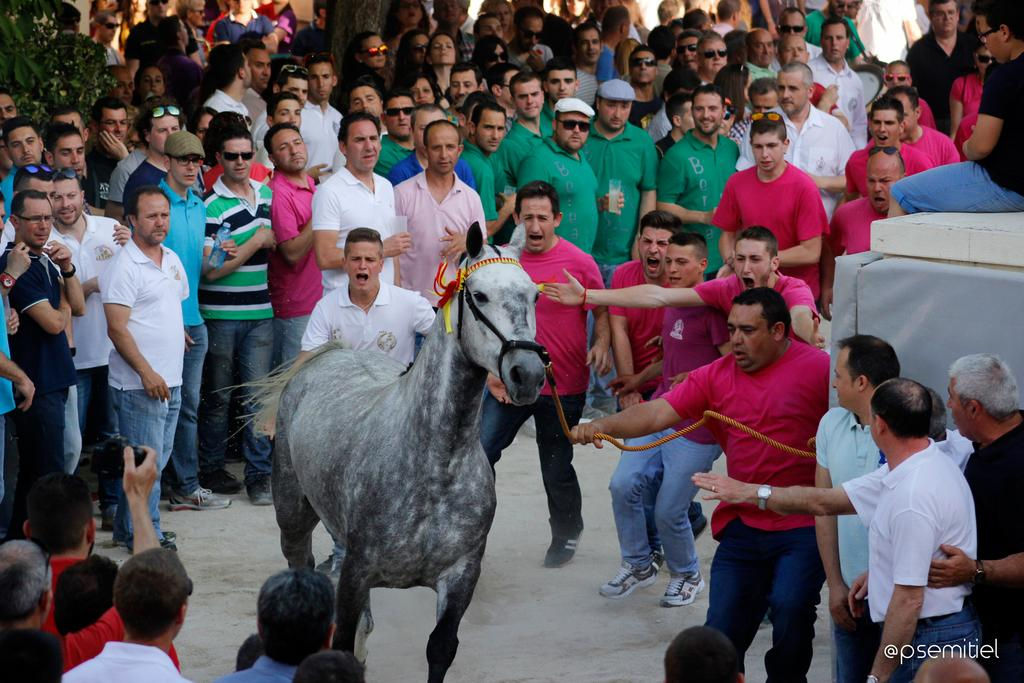Who is present in the image? There is a man in the image. What is the man doing in the image? The man is behind a horse. Are there any other people in the image? Yes, there is a group of people standing in the image. What type of mailbox can be seen near the man in the image? There is no mailbox present in the image. Is the man wearing a mitten in the image? There is no information about the man's clothing, including mittens, in the image. 